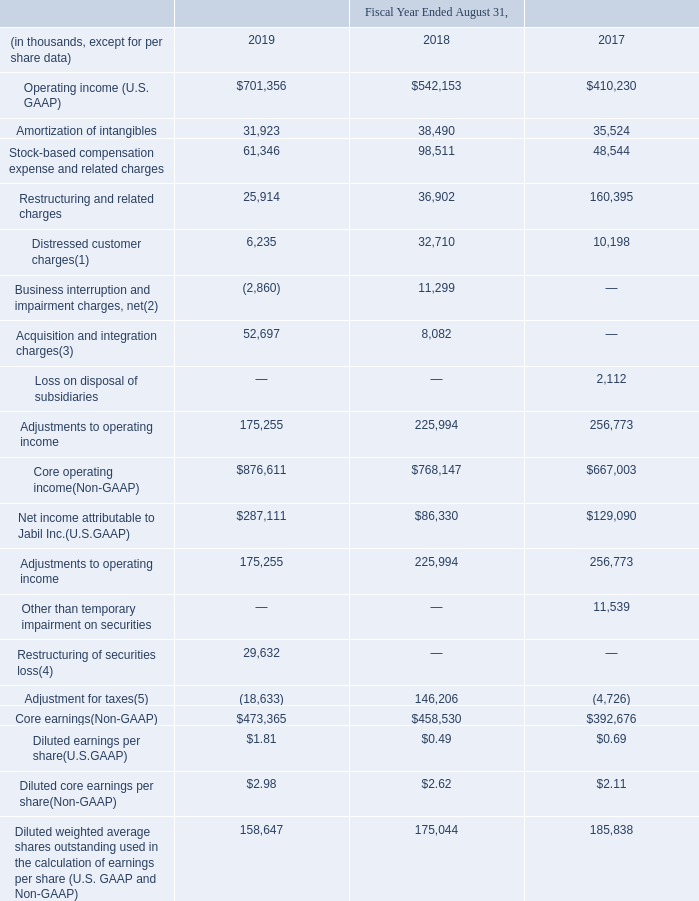Non-GAAP (Core) Financial Measures
The following discussion and analysis of our financial condition and results of operations include certain non-GAAP financial measures as identified in the reconciliation below. The non-GAAP financial measures disclosed herein do not have standard meaning and may vary from the non-GAAP financial measures used by other companies or how we may calculate those measures in other instances from time to time. Non-GAAP financial measures should not be considered a substitute for, or superior to, measures of financial performance prepared in accordance with U.S. GAAP. Also, our “core” financial measures should not be construed as an inference by us that our future results will be unaffected by those items that are excluded from our “core” financial measures.
Management believes that the non-GAAP “core” financial measures set forth below are useful to facilitate evaluating the past and future performance of our ongoing manufacturing operations over multiple periods on a comparable basis by excluding the effects of the amortization of intangibles, stock-based compensation expense and related charges, restructuring and related charges, distressed customer charges, acquisition and integration charges, loss on disposal of subsidiaries, settlement of receivables and related charges, impairment of notes receivable and related charges, goodwill impairment charges, business interruption and impairment charges, net, other than temporary impairment on securities, restructuring of securities loss, income (loss) from discontinued operations, gain (loss) on sale of discontinued operations and certain other expenses, net of tax and certain deferred tax valuation allowance charges. Among other uses, management uses non-GAAP “core” financial measures to make operating decisions, assess business performance and as a factor in determining certain employee performance when evaluating incentive compensation. Management believes that the non-GAAP “core” financial measures set forth below are useful to facilitate evaluating the past and future performance of our ongoing manufacturing operations over multiple periods on a comparable basis by excluding the effects of the amortization of intangibles, stock-based compensation expense and related charges, restructuring and related charges, distressed customer charges, acquisition and integration charges, loss on disposal of subsidiaries, settlement of receivables and related charges, impairment of notes receivable and related charges, goodwill impairment charges, business interruption and impairment charges, net, other than temporary impairment on securities, restructuring of securities loss, income (loss) from discontinued operations, gain (loss) on sale of discontinued operations and certain other expenses, net of tax and certain deferred tax valuation allowance charges. Among other uses, management uses non-GAAP “core” financial measures to make operating decisions, assess business performance and as a factor in determining certain employee performance when evaluating incentive compensation. Management believes that the non-GAAP “core” financial measures set forth below are useful to facilitate evaluating the past and future performance of our ongoing manufacturing operations over multiple periods on a comparable basis by excluding the effects of the amortization of intangibles, stock-based compensation expense and related charges, restructuring and related charges, distressed customer charges, acquisition and integration charges, loss on disposal of subsidiaries, settlement of receivables and related charges, impairment of notes receivable and related charges, goodwill impairment charges, business interruption and impairment charges, net, other than temporary impairment on securities, restructuring of securities loss, income (loss) from discontinued operations, gain (loss) on sale of discontinued operations and certain other expenses, net of tax and certain deferred tax valuation allowance charges. Among other uses, management uses non-GAAP “core” financial measures to make operating decisions, assess business performance and as a factor in determining certain employee performance when evaluating incentive compensation.
We determine the tax effect of the items excluded from “core” earnings and “core” diluted earnings per share based upon evaluation of the statutory tax treatment and the applicable tax rate of the jurisdiction in which the pre-tax items were incurred, and for which realization of the resulting tax benefit, if any, is expected. In certain jurisdictions where we do not expect to realize a tax benefit (due to existing tax incentives or a history of operating losses or other factors resulting in a valuation allowance related to deferred tax assets), a reduced or 0% tax rate is applied.
We are reporting “core” operating income, “core” earnings and “core” return on invested capital to provide investors with an additional method for assessing operating income and earnings, by presenting what we believe are our “core” manufacturing operations. A significant portion (based on the respective values) of the items that are excluded for purposes of calculating “core” operating income and “core” earnings also impacted certain balance sheet assets, resulting in a portion of an asset being written off without a corresponding recovery of cash we may have previously spent with respect to the asset. In the case of restructuring and related charges, we may make associated cash payments in the future. In addition, although, for purposes of calculating “core” operating income and “core” earnings, we exclude stock-based compensation expense (which we anticipate continuing to incur in the future) because it is a non-cash expense, the associated stock issued may result in an increase in our outstanding shares of stock, which may result in the dilution of our stockholders’ ownership interest. We encourage you to consider these matters when evaluating the utility of these non-GAAP financial measures.
Included in the tables below are a reconciliation of the non-GAAP financial measures to the most directly comparable U.S. GAAP financial measures as provided in our Consolidated Financial Statements:
Reconciliation of U.S. GAAP Financial Results to Non-GAAP Measures
(1) Charges during fiscal years 2019 and 2018 relate to inventory and other assets charges for certain distressed customers in the networking and consumer wearables sectors. Charges during fiscal year 2017 relate to inventory and other assets charges for the disengagement with an energy customer.
(2) Charges, net of insurance proceeds of $2.9 million and $24.9 million, for the fiscal years ended August 31, 2019 and 2018, respectively, relate to business interruption and asset impairment costs associated with damage from Hurricane Maria, which impacted our operations in Cayey, Puerto Rico.
(3) Charges related to our strategic collaboration with Johnson & Johnson Medical Devices Companies (“JJMD”).
(4) Relates to a restructuring of securities loss on available for sale securities during fiscal year 2019. See Note 16 – “Fair Value Measurements” to the Consolidated Financial Statements for further discussion.
(5) The fiscal year ended August 31, 2019 includes a $13.3 million income tax benefit for the effects of the Tax Act recorded during the three months ended November 30, 2018. The fiscal year ended August 31, 2018 includes a $142.3 million provisional estimate to account for the effects of the Tax Act.
Which fiscal years do charges relate to inventory and other assets charges for certain distressed customers in the networking and consumer wearables sectors? 2019, 2018. What were the insurance proceeds for the fiscal year ended August 31, 2019? $2.9 million. What were the Amortization of intangibles in 2019?
Answer scale should be: thousand. 31,923. What was the change in Restructuring and related charges between 2018 and 2019?
Answer scale should be: thousand. 25,914-36,902
Answer: -10988. How many years did Operating income (U.S. GAAP) exceed $500,000 thousand? 2019##2018
Answer: 2. What was the percentage change in Net income attributable to Jabil Inc.(U.S.GAAP) between 2018 and 2019?
Answer scale should be: percent. ($287,111-$86,330)/$86,330
Answer: 232.57. 